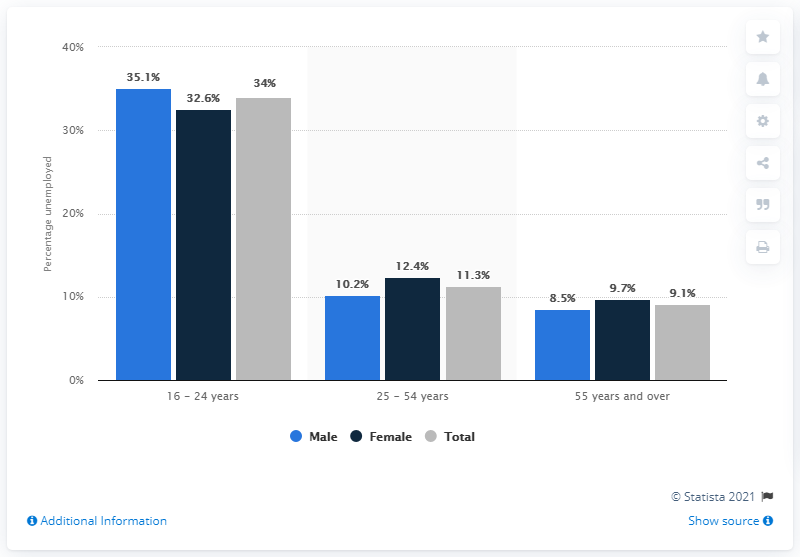Outline some significant characteristics in this image. What number is the second tallest navy blue bar? In 2020, Catalonia's unemployment rate was 11.3%. The female unemployment rate for individuals aged 55 years and older is closest to the total unemployment rate. 